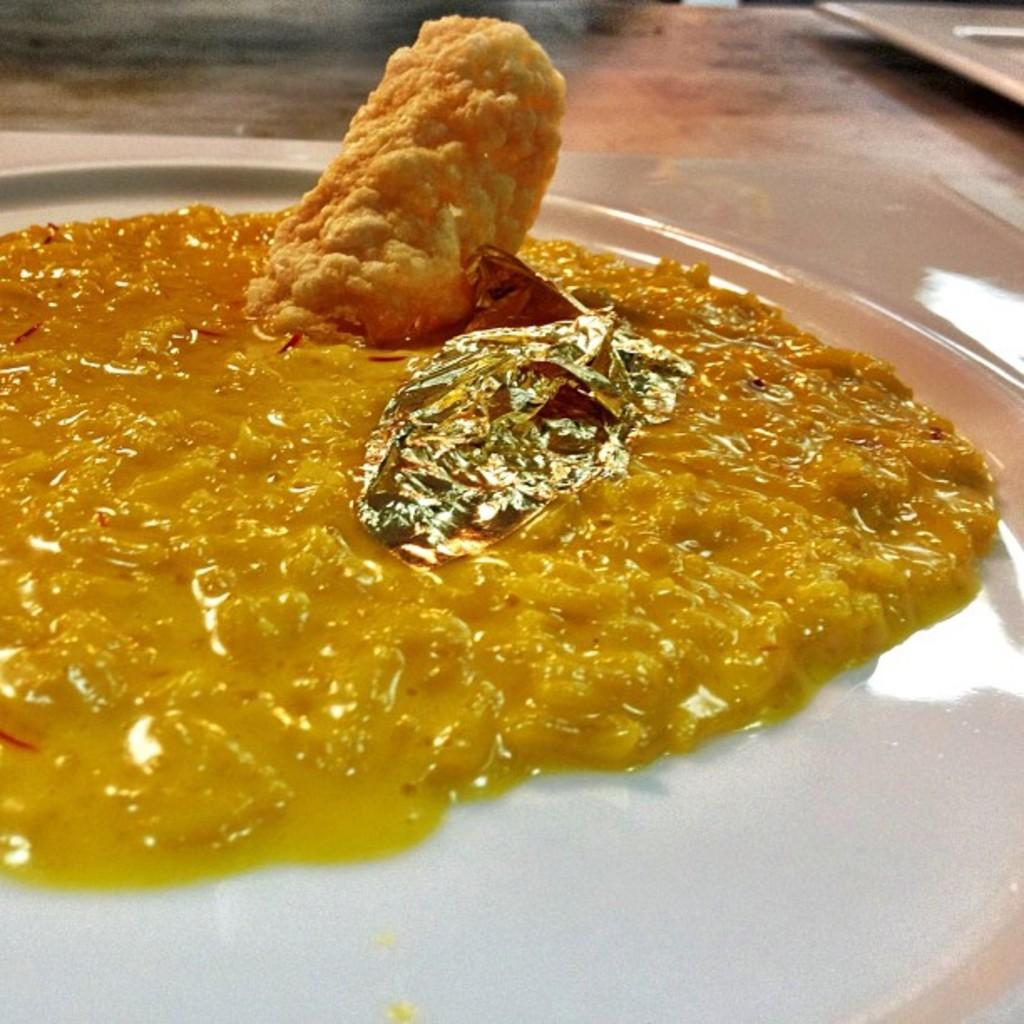What color is the plate that holds the food in the image? The plate is white. What is the color of the food on the plate? The food is in yellow color. Where is the plate with the food located? The plate is placed on a table. What type of news can be heard coming from the radio in the image? There is no radio or news present in the image; it only features a plate of yellow food on a white plate placed on a table. 